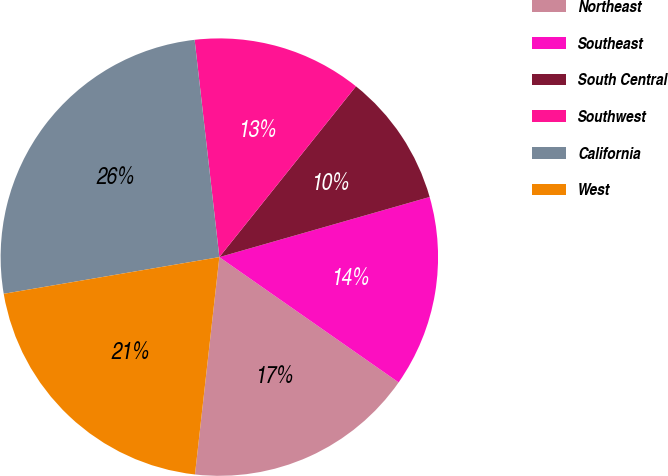Convert chart. <chart><loc_0><loc_0><loc_500><loc_500><pie_chart><fcel>Northeast<fcel>Southeast<fcel>South Central<fcel>Southwest<fcel>California<fcel>West<nl><fcel>17.07%<fcel>14.14%<fcel>9.83%<fcel>12.54%<fcel>25.88%<fcel>20.54%<nl></chart> 